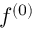<formula> <loc_0><loc_0><loc_500><loc_500>f ^ { ( 0 ) }</formula> 